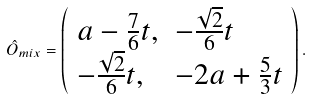<formula> <loc_0><loc_0><loc_500><loc_500>\hat { O } _ { m i x } = \left ( \begin{array} { l l } a - \frac { 7 } { 6 } t , & - \frac { \sqrt { 2 } } { 6 } t \\ - \frac { \sqrt { 2 } } { 6 } t , & - 2 a + \frac { 5 } { 3 } t \end{array} \right ) .</formula> 